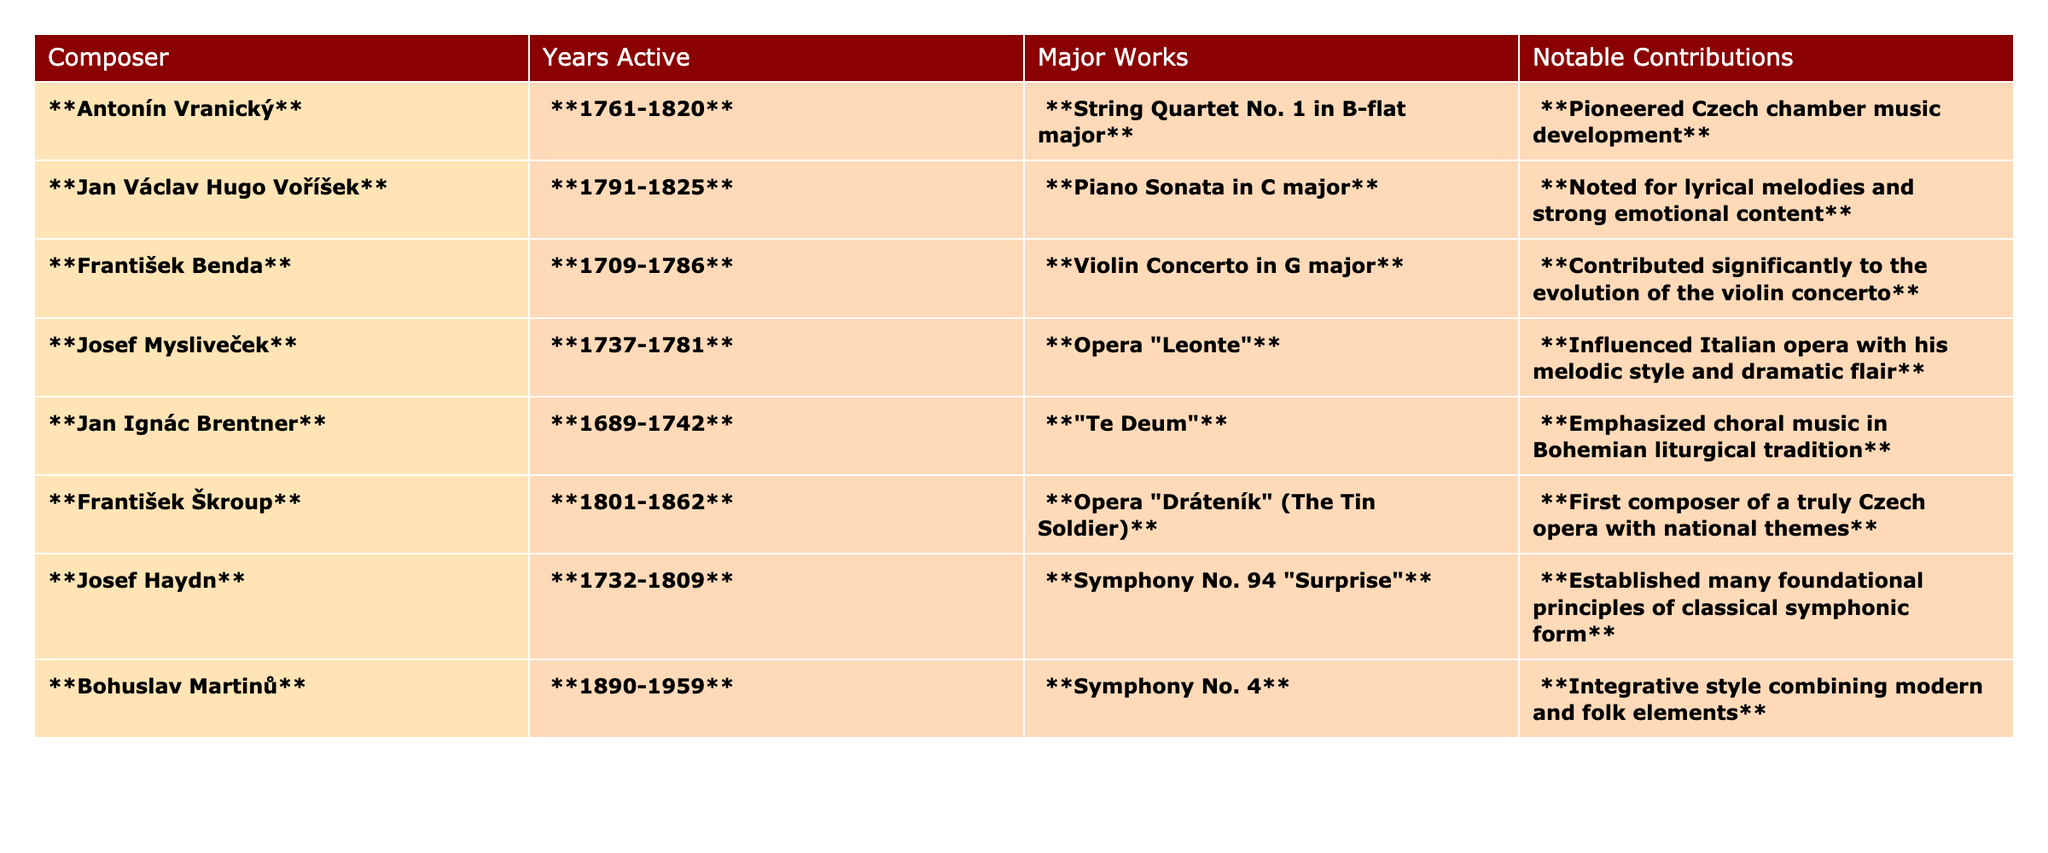What are the years of activity for Antonín Vranický? The table lists the years for Antonín Vranický as "1761-1820."
Answer: 1761-1820 Which composer is noted for the influence on Italian opera? The composer who influenced Italian opera, according to the table, is Josef Mysliveček, who is known for his melodic style and dramatic flair.
Answer: Josef Mysliveček What is the major work of František Benda? The table indicates that František Benda's major work is the "Violin Concerto in G major."
Answer: Violin Concerto in G major Is Jan Ignác Brentner recognized for his contributions to choral music? Yes, according to the table, Jan Ignác Brentner is noted for emphasizing choral music in Bohemian liturgical tradition.
Answer: Yes Which composer has the earliest years of activity listed? The table shows Jan Ignác Brentner with active years from 1689-1742 as the earliest.
Answer: Jan Ignác Brentner How many composers listed were active in the 18th century? Analyzing the table, five composers fall within the 18th century (Antonín Vranický, Jan Václav Hugo Voříšek, František Benda, Josef Mysliveček, Jan Ignác Brentner).
Answer: 5 What is the notable contribution of František Škroup? The table states that František Škroup's notable contribution was being the first composer of a truly Czech opera with national themes.
Answer: First composer of a truly Czech opera Which composer has a major work that emphasizes emotional content? The table states that Jan Václav Hugo Voříšek's "Piano Sonata in C major" is noted for its lyrical melodies and strong emotional content.
Answer: Jan Václav Hugo Voříšek If you combine the notable contributions of Antonín Vranický and František Benda, what can you infer about their influence in Czech music? Antonín Vranický pioneered Czech chamber music, while František Benda significantly contributed to the evolution of the violin concerto; together, they represent critical advancements in both chamber and orchestral music in Czech history.
Answer: They represent critical advancements in Czech music How does the notable contribution of Josef Haydn compare with Josef Mysliveček? Josef Haydn established foundational principles of classical symphonic form, while Josef Mysliveček influenced Italian opera with his melodic style; both were pivotal but focused on different aspects of music development—symphonic versus operatic styles.
Answer: They focused on different aspects of music development 